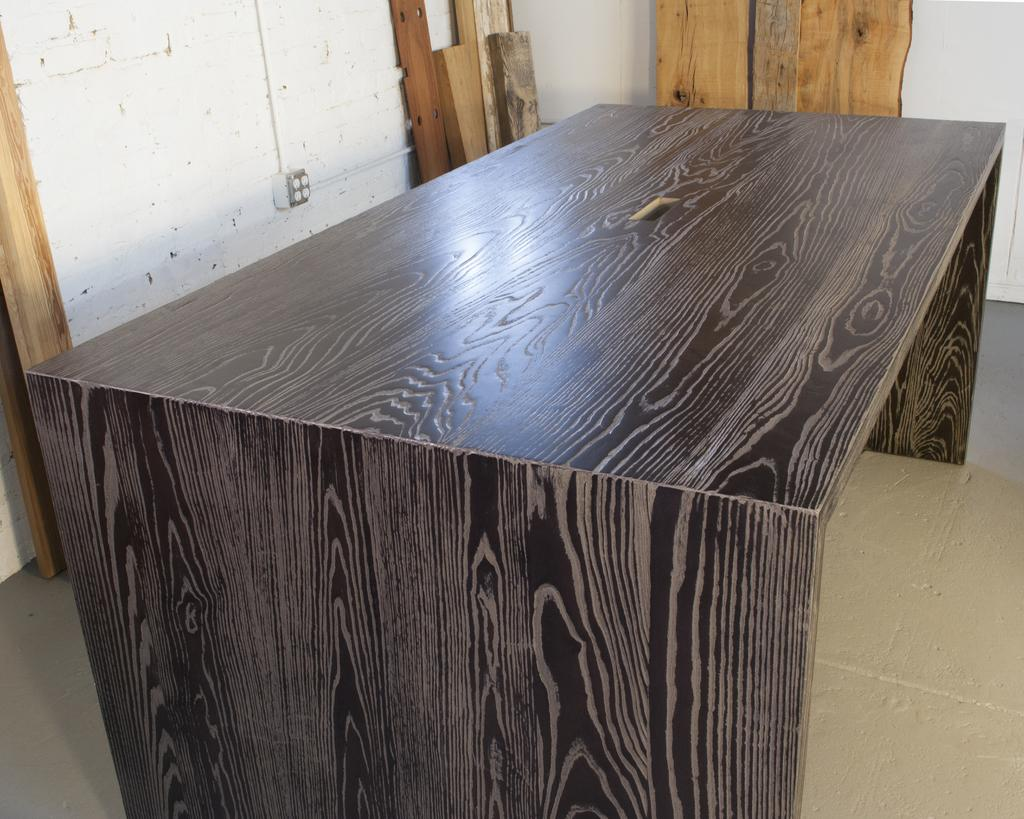What type of furniture is on the floor in the image? There is a table on the floor in the image. What can be seen in the background of the image? There is a wall visible in the image. What material are the objects made of in the image? There are wooden objects in the image. What advice is being given in the image? There is no indication of anyone giving advice in the image. What error is being corrected in the image? There is no error being corrected in the image. Is there a fight happening in the image? There is no fight depicted in the image. 